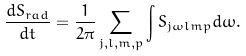<formula> <loc_0><loc_0><loc_500><loc_500>\frac { d S _ { r a d } } { d t } = \frac { 1 } { 2 \pi } \sum _ { j , l , m , p } \int S _ { j \omega l m p } d \omega .</formula> 